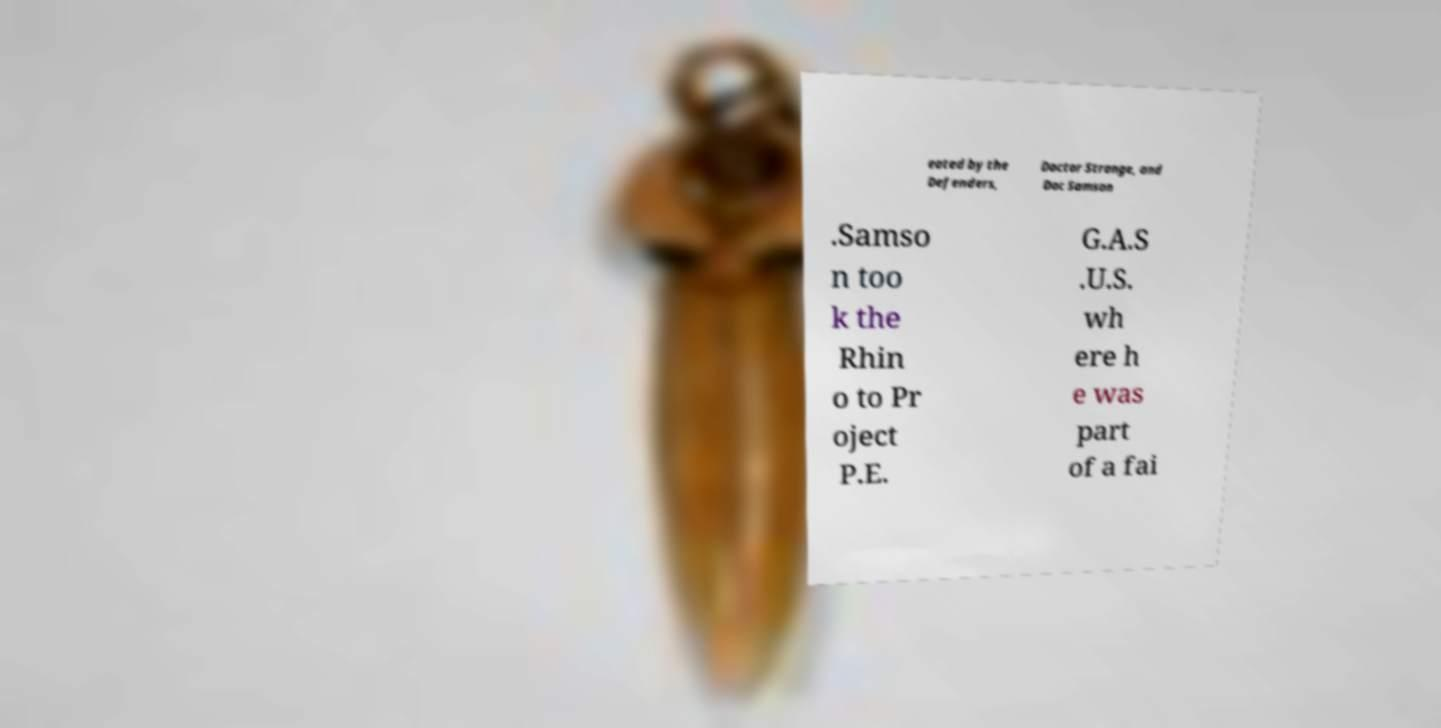For documentation purposes, I need the text within this image transcribed. Could you provide that? eated by the Defenders, Doctor Strange, and Doc Samson .Samso n too k the Rhin o to Pr oject P.E. G.A.S .U.S. wh ere h e was part of a fai 